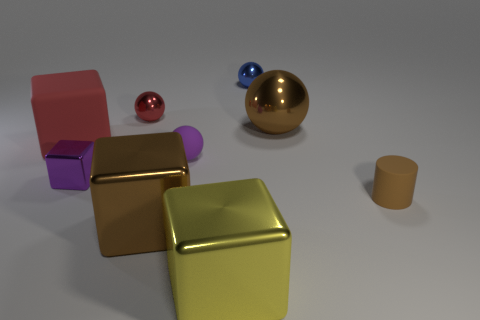Subtract all red balls. How many balls are left? 3 Subtract all big brown balls. How many balls are left? 3 Subtract 2 balls. How many balls are left? 2 Subtract all green balls. Subtract all blue cylinders. How many balls are left? 4 Add 1 matte cylinders. How many objects exist? 10 Subtract all cylinders. How many objects are left? 8 Add 7 yellow cylinders. How many yellow cylinders exist? 7 Subtract 0 green cubes. How many objects are left? 9 Subtract all big metallic things. Subtract all tiny purple metallic cubes. How many objects are left? 5 Add 3 blue spheres. How many blue spheres are left? 4 